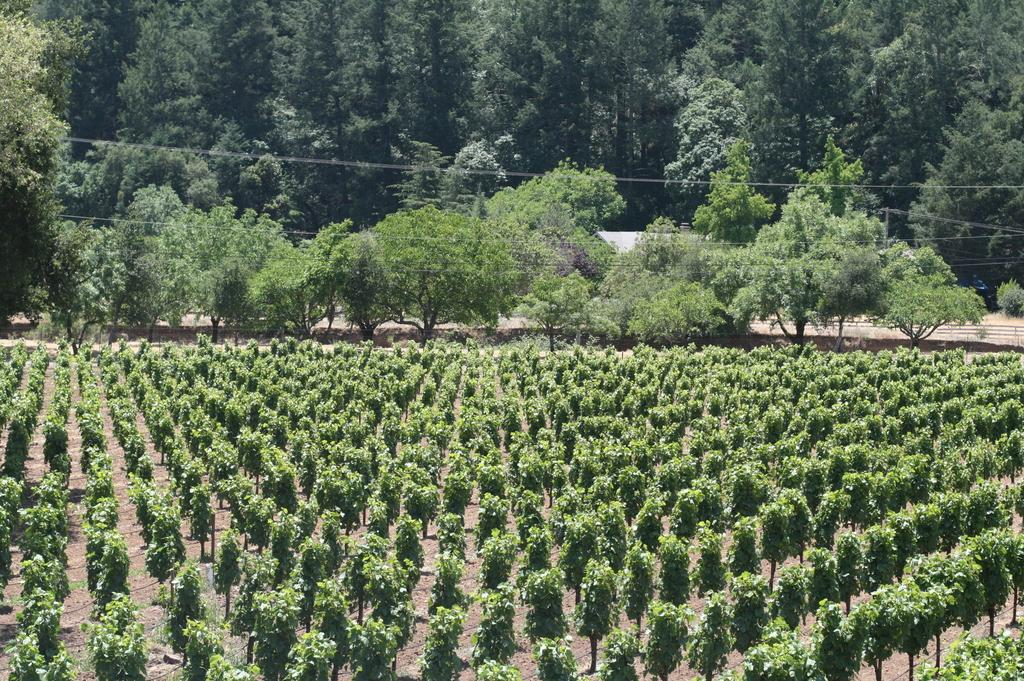What is the main feature of the image? There is a field in the image. What can be seen in the background of the field? There are plenty of trees behind the field in the image. How many cats are playing in the field in the image? There are no cats present in the image; it only features a field and trees in the background. 